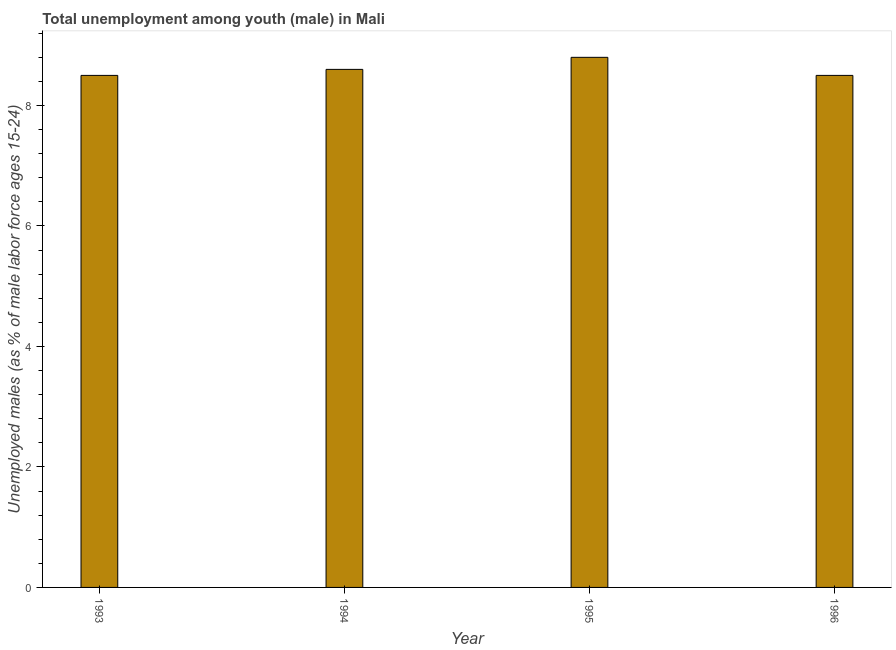Does the graph contain any zero values?
Give a very brief answer. No. What is the title of the graph?
Your answer should be very brief. Total unemployment among youth (male) in Mali. What is the label or title of the Y-axis?
Keep it short and to the point. Unemployed males (as % of male labor force ages 15-24). What is the unemployed male youth population in 1993?
Your answer should be compact. 8.5. Across all years, what is the maximum unemployed male youth population?
Your answer should be very brief. 8.8. What is the sum of the unemployed male youth population?
Provide a succinct answer. 34.4. What is the difference between the unemployed male youth population in 1993 and 1995?
Offer a very short reply. -0.3. What is the average unemployed male youth population per year?
Ensure brevity in your answer.  8.6. What is the median unemployed male youth population?
Your response must be concise. 8.55. In how many years, is the unemployed male youth population greater than 2 %?
Your answer should be compact. 4. Do a majority of the years between 1994 and 1996 (inclusive) have unemployed male youth population greater than 0.8 %?
Give a very brief answer. Yes. What is the ratio of the unemployed male youth population in 1993 to that in 1995?
Provide a short and direct response. 0.97. Is the unemployed male youth population in 1994 less than that in 1996?
Offer a terse response. No. Is the difference between the unemployed male youth population in 1995 and 1996 greater than the difference between any two years?
Give a very brief answer. Yes. What is the difference between the highest and the second highest unemployed male youth population?
Make the answer very short. 0.2. What is the difference between the highest and the lowest unemployed male youth population?
Ensure brevity in your answer.  0.3. In how many years, is the unemployed male youth population greater than the average unemployed male youth population taken over all years?
Your answer should be compact. 2. How many bars are there?
Your answer should be compact. 4. How many years are there in the graph?
Give a very brief answer. 4. What is the Unemployed males (as % of male labor force ages 15-24) of 1994?
Give a very brief answer. 8.6. What is the Unemployed males (as % of male labor force ages 15-24) in 1995?
Your response must be concise. 8.8. What is the difference between the Unemployed males (as % of male labor force ages 15-24) in 1993 and 1994?
Give a very brief answer. -0.1. What is the difference between the Unemployed males (as % of male labor force ages 15-24) in 1993 and 1996?
Provide a short and direct response. 0. What is the ratio of the Unemployed males (as % of male labor force ages 15-24) in 1993 to that in 1994?
Make the answer very short. 0.99. What is the ratio of the Unemployed males (as % of male labor force ages 15-24) in 1993 to that in 1995?
Make the answer very short. 0.97. What is the ratio of the Unemployed males (as % of male labor force ages 15-24) in 1993 to that in 1996?
Provide a short and direct response. 1. What is the ratio of the Unemployed males (as % of male labor force ages 15-24) in 1995 to that in 1996?
Keep it short and to the point. 1.03. 